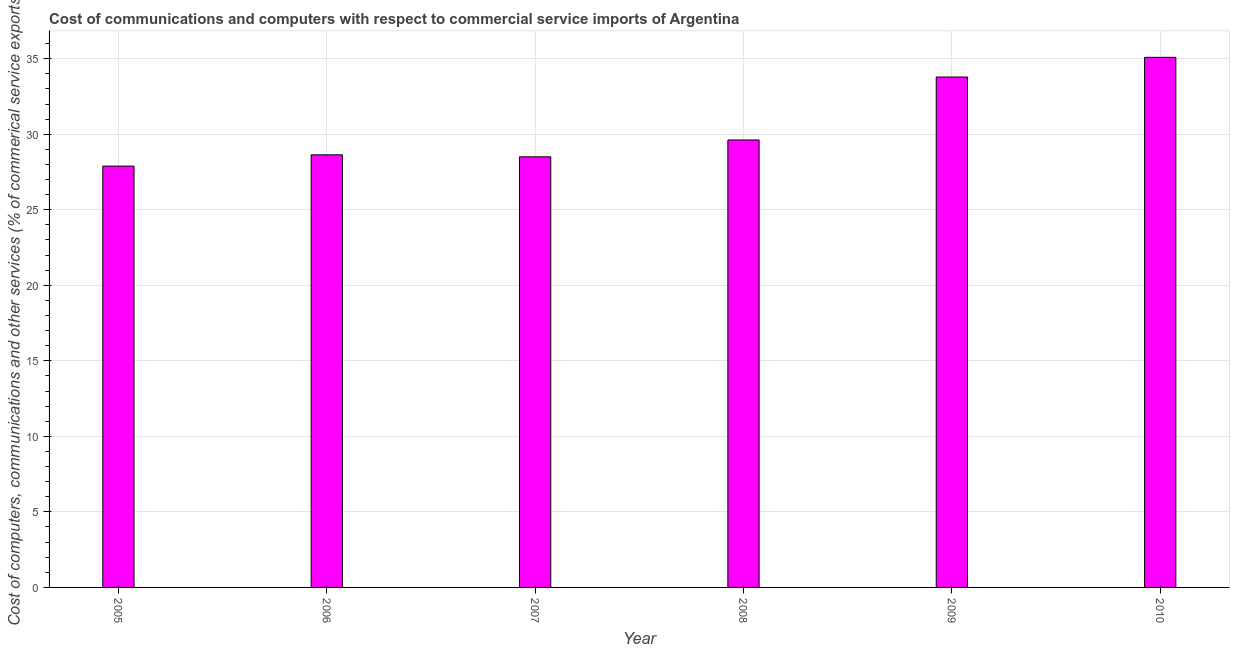Does the graph contain any zero values?
Provide a succinct answer. No. What is the title of the graph?
Offer a terse response. Cost of communications and computers with respect to commercial service imports of Argentina. What is the label or title of the Y-axis?
Provide a succinct answer. Cost of computers, communications and other services (% of commerical service exports). What is the cost of communications in 2008?
Keep it short and to the point. 29.62. Across all years, what is the maximum  computer and other services?
Offer a very short reply. 35.09. Across all years, what is the minimum  computer and other services?
Your answer should be very brief. 27.89. What is the sum of the  computer and other services?
Ensure brevity in your answer.  183.53. What is the difference between the cost of communications in 2009 and 2010?
Provide a short and direct response. -1.3. What is the average cost of communications per year?
Give a very brief answer. 30.59. What is the median cost of communications?
Your response must be concise. 29.13. What is the ratio of the  computer and other services in 2007 to that in 2009?
Offer a terse response. 0.84. What is the difference between the highest and the second highest  computer and other services?
Your answer should be compact. 1.3. What is the difference between the highest and the lowest  computer and other services?
Your response must be concise. 7.2. How many bars are there?
Your answer should be very brief. 6. What is the Cost of computers, communications and other services (% of commerical service exports) in 2005?
Keep it short and to the point. 27.89. What is the Cost of computers, communications and other services (% of commerical service exports) of 2006?
Keep it short and to the point. 28.64. What is the Cost of computers, communications and other services (% of commerical service exports) in 2007?
Your answer should be compact. 28.5. What is the Cost of computers, communications and other services (% of commerical service exports) in 2008?
Your answer should be compact. 29.62. What is the Cost of computers, communications and other services (% of commerical service exports) in 2009?
Offer a terse response. 33.79. What is the Cost of computers, communications and other services (% of commerical service exports) of 2010?
Provide a short and direct response. 35.09. What is the difference between the Cost of computers, communications and other services (% of commerical service exports) in 2005 and 2006?
Give a very brief answer. -0.75. What is the difference between the Cost of computers, communications and other services (% of commerical service exports) in 2005 and 2007?
Ensure brevity in your answer.  -0.61. What is the difference between the Cost of computers, communications and other services (% of commerical service exports) in 2005 and 2008?
Your answer should be very brief. -1.73. What is the difference between the Cost of computers, communications and other services (% of commerical service exports) in 2005 and 2009?
Ensure brevity in your answer.  -5.9. What is the difference between the Cost of computers, communications and other services (% of commerical service exports) in 2005 and 2010?
Your answer should be very brief. -7.2. What is the difference between the Cost of computers, communications and other services (% of commerical service exports) in 2006 and 2007?
Your response must be concise. 0.13. What is the difference between the Cost of computers, communications and other services (% of commerical service exports) in 2006 and 2008?
Make the answer very short. -0.98. What is the difference between the Cost of computers, communications and other services (% of commerical service exports) in 2006 and 2009?
Give a very brief answer. -5.15. What is the difference between the Cost of computers, communications and other services (% of commerical service exports) in 2006 and 2010?
Give a very brief answer. -6.45. What is the difference between the Cost of computers, communications and other services (% of commerical service exports) in 2007 and 2008?
Your answer should be compact. -1.12. What is the difference between the Cost of computers, communications and other services (% of commerical service exports) in 2007 and 2009?
Your answer should be compact. -5.28. What is the difference between the Cost of computers, communications and other services (% of commerical service exports) in 2007 and 2010?
Your answer should be compact. -6.59. What is the difference between the Cost of computers, communications and other services (% of commerical service exports) in 2008 and 2009?
Give a very brief answer. -4.17. What is the difference between the Cost of computers, communications and other services (% of commerical service exports) in 2008 and 2010?
Ensure brevity in your answer.  -5.47. What is the difference between the Cost of computers, communications and other services (% of commerical service exports) in 2009 and 2010?
Ensure brevity in your answer.  -1.3. What is the ratio of the Cost of computers, communications and other services (% of commerical service exports) in 2005 to that in 2006?
Your answer should be very brief. 0.97. What is the ratio of the Cost of computers, communications and other services (% of commerical service exports) in 2005 to that in 2008?
Your answer should be compact. 0.94. What is the ratio of the Cost of computers, communications and other services (% of commerical service exports) in 2005 to that in 2009?
Offer a terse response. 0.82. What is the ratio of the Cost of computers, communications and other services (% of commerical service exports) in 2005 to that in 2010?
Keep it short and to the point. 0.8. What is the ratio of the Cost of computers, communications and other services (% of commerical service exports) in 2006 to that in 2007?
Offer a terse response. 1. What is the ratio of the Cost of computers, communications and other services (% of commerical service exports) in 2006 to that in 2008?
Your response must be concise. 0.97. What is the ratio of the Cost of computers, communications and other services (% of commerical service exports) in 2006 to that in 2009?
Your answer should be very brief. 0.85. What is the ratio of the Cost of computers, communications and other services (% of commerical service exports) in 2006 to that in 2010?
Provide a short and direct response. 0.82. What is the ratio of the Cost of computers, communications and other services (% of commerical service exports) in 2007 to that in 2009?
Offer a very short reply. 0.84. What is the ratio of the Cost of computers, communications and other services (% of commerical service exports) in 2007 to that in 2010?
Your response must be concise. 0.81. What is the ratio of the Cost of computers, communications and other services (% of commerical service exports) in 2008 to that in 2009?
Ensure brevity in your answer.  0.88. What is the ratio of the Cost of computers, communications and other services (% of commerical service exports) in 2008 to that in 2010?
Provide a short and direct response. 0.84. What is the ratio of the Cost of computers, communications and other services (% of commerical service exports) in 2009 to that in 2010?
Your response must be concise. 0.96. 